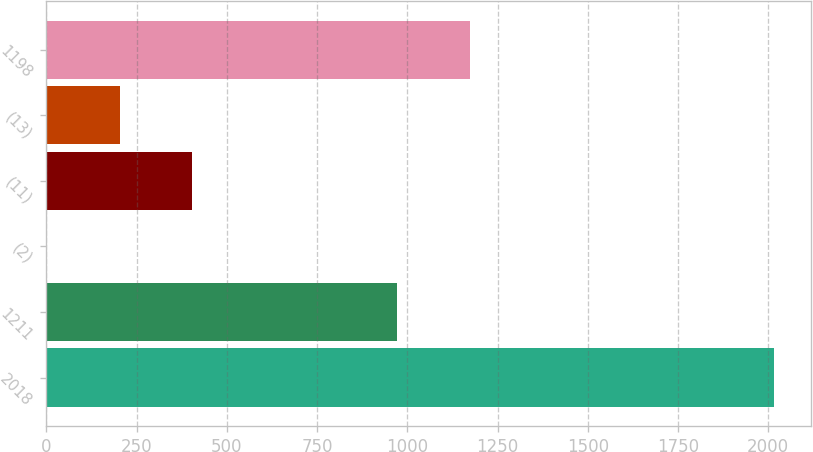Convert chart to OTSL. <chart><loc_0><loc_0><loc_500><loc_500><bar_chart><fcel>2018<fcel>1211<fcel>(2)<fcel>(11)<fcel>(13)<fcel>1198<nl><fcel>2017<fcel>971<fcel>1<fcel>404.2<fcel>202.6<fcel>1172.6<nl></chart> 